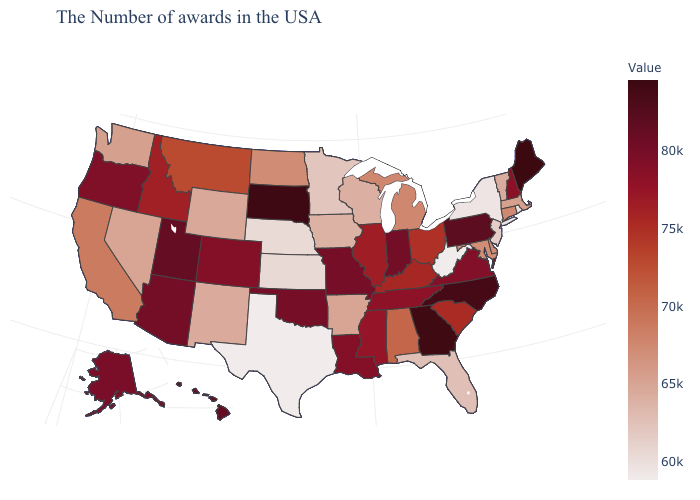Does Maine have a lower value than Ohio?
Keep it brief. No. Which states have the highest value in the USA?
Answer briefly. Maine. Which states have the lowest value in the West?
Quick response, please. New Mexico. Does West Virginia have the lowest value in the USA?
Keep it brief. Yes. 